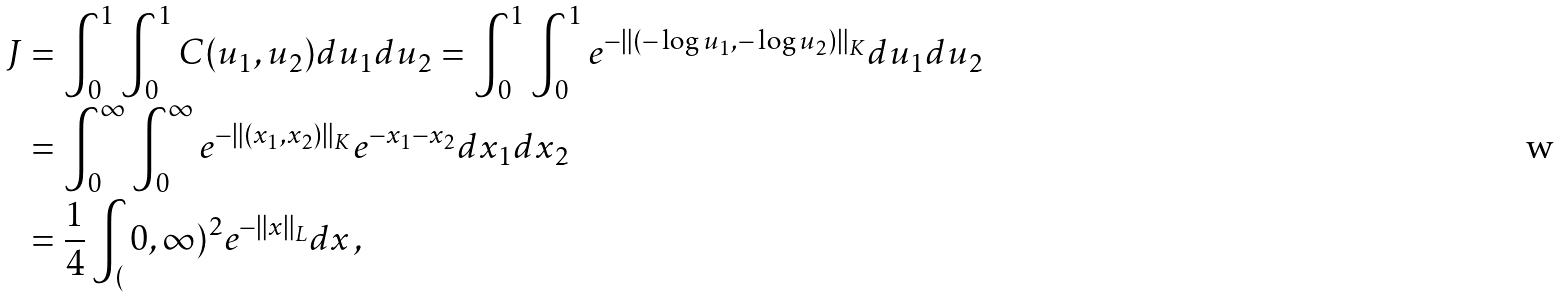Convert formula to latex. <formula><loc_0><loc_0><loc_500><loc_500>J & = \int _ { 0 } ^ { 1 } \int _ { 0 } ^ { 1 } C ( u _ { 1 } , u _ { 2 } ) d u _ { 1 } d u _ { 2 } = \int _ { 0 } ^ { 1 } \int _ { 0 } ^ { 1 } e ^ { - \| ( - \log u _ { 1 } , - \log u _ { 2 } ) \| _ { K } } d u _ { 1 } d u _ { 2 } \\ & = \int _ { 0 } ^ { \infty } \int _ { 0 } ^ { \infty } e ^ { - \| ( x _ { 1 } , x _ { 2 } ) \| _ { K } } e ^ { - x _ { 1 } - x _ { 2 } } d x _ { 1 } d x _ { 2 } \\ & = \frac { 1 } { 4 } \int _ { ( } 0 , \infty ) ^ { 2 } e ^ { - \| x \| _ { L } } d x \, ,</formula> 